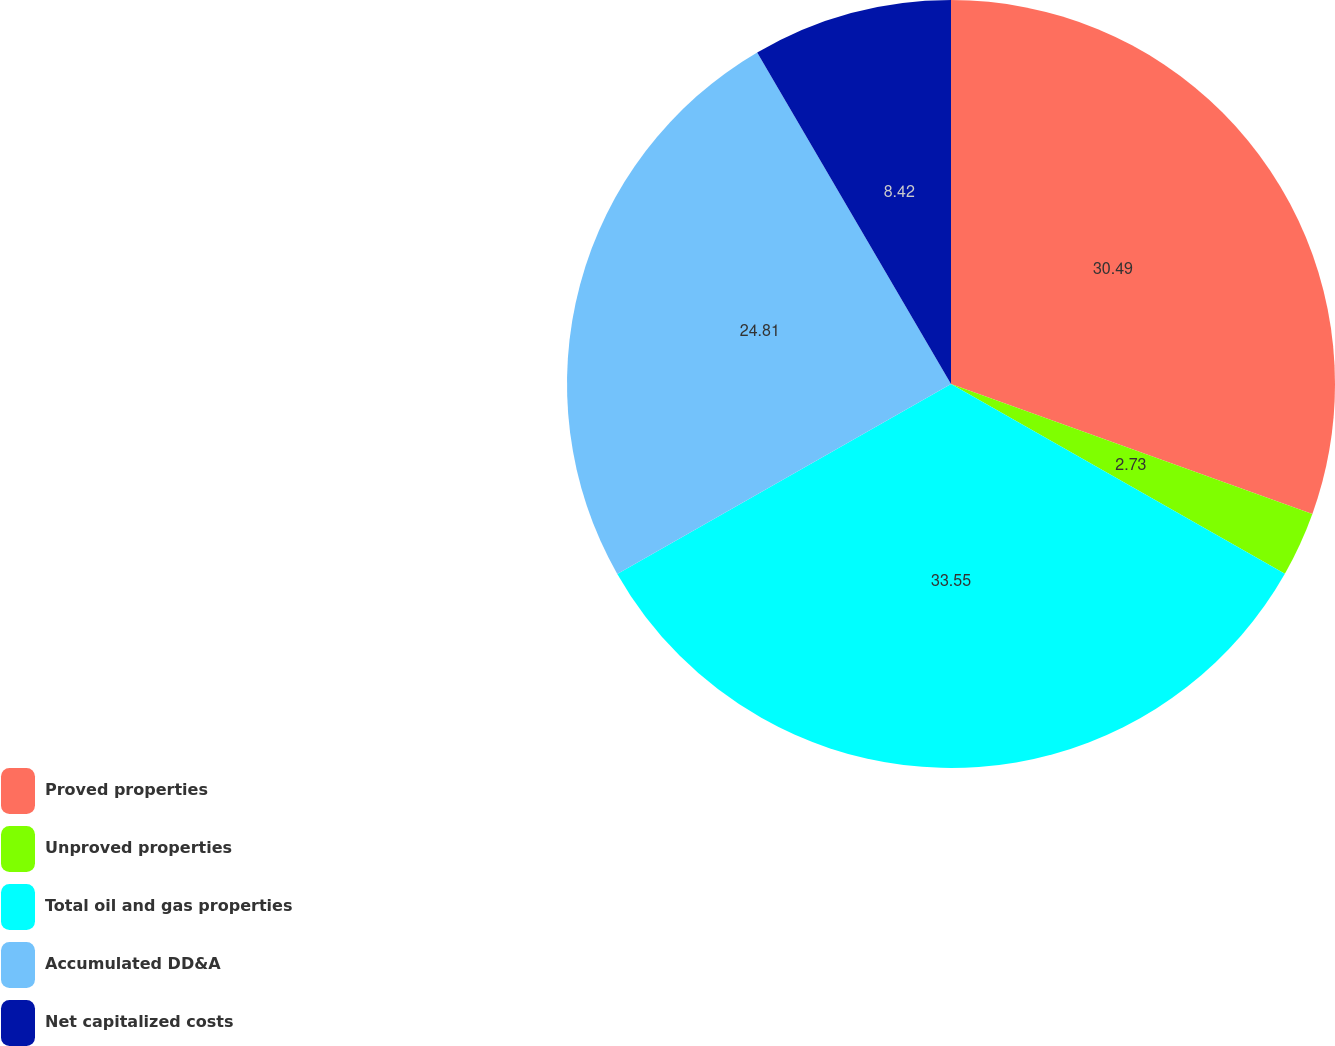Convert chart. <chart><loc_0><loc_0><loc_500><loc_500><pie_chart><fcel>Proved properties<fcel>Unproved properties<fcel>Total oil and gas properties<fcel>Accumulated DD&A<fcel>Net capitalized costs<nl><fcel>30.49%<fcel>2.73%<fcel>33.54%<fcel>24.81%<fcel>8.42%<nl></chart> 